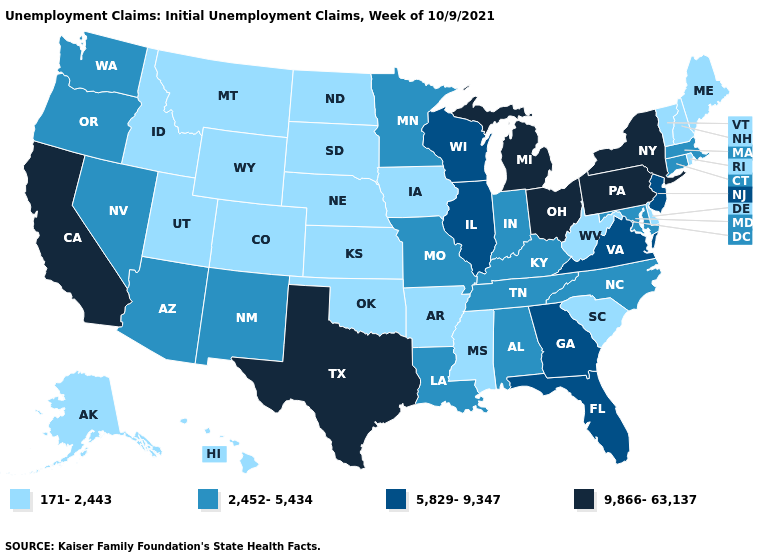Name the states that have a value in the range 9,866-63,137?
Keep it brief. California, Michigan, New York, Ohio, Pennsylvania, Texas. Does Oregon have the same value as Montana?
Keep it brief. No. Which states have the lowest value in the USA?
Keep it brief. Alaska, Arkansas, Colorado, Delaware, Hawaii, Idaho, Iowa, Kansas, Maine, Mississippi, Montana, Nebraska, New Hampshire, North Dakota, Oklahoma, Rhode Island, South Carolina, South Dakota, Utah, Vermont, West Virginia, Wyoming. What is the value of Delaware?
Keep it brief. 171-2,443. What is the value of Ohio?
Answer briefly. 9,866-63,137. Name the states that have a value in the range 5,829-9,347?
Quick response, please. Florida, Georgia, Illinois, New Jersey, Virginia, Wisconsin. Does Colorado have the lowest value in the West?
Keep it brief. Yes. What is the highest value in the USA?
Answer briefly. 9,866-63,137. Does the first symbol in the legend represent the smallest category?
Write a very short answer. Yes. What is the lowest value in states that border Ohio?
Quick response, please. 171-2,443. What is the value of Illinois?
Short answer required. 5,829-9,347. What is the value of Vermont?
Keep it brief. 171-2,443. How many symbols are there in the legend?
Answer briefly. 4. Among the states that border Nevada , which have the lowest value?
Concise answer only. Idaho, Utah. What is the value of Massachusetts?
Concise answer only. 2,452-5,434. 